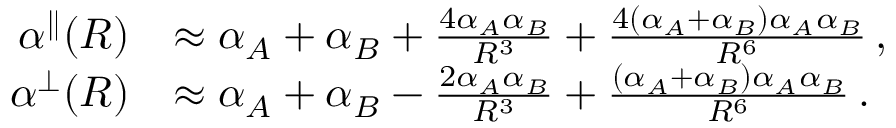Convert formula to latex. <formula><loc_0><loc_0><loc_500><loc_500>\begin{array} { r l } { \alpha ^ { \| } ( R ) } & { \approx \alpha _ { A } + \alpha _ { B } + \frac { 4 \alpha _ { A } \alpha _ { B } } { R ^ { 3 } } + \frac { 4 ( \alpha _ { A } + \alpha _ { B } ) \alpha _ { A } \alpha _ { B } } { R ^ { 6 } } \, , } \\ { \alpha ^ { \perp } ( R ) } & { \approx \alpha _ { A } + \alpha _ { B } - \frac { 2 \alpha _ { A } \alpha _ { B } } { R ^ { 3 } } + \frac { ( \alpha _ { A } + \alpha _ { B } ) \alpha _ { A } \alpha _ { B } } { R ^ { 6 } } \, . } \end{array}</formula> 